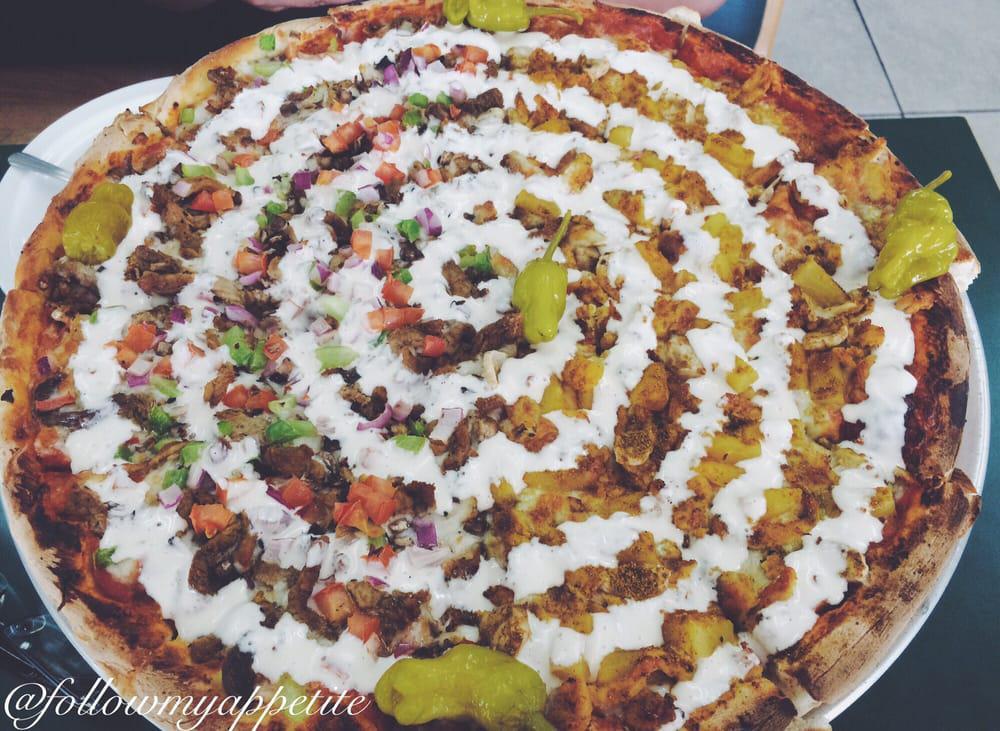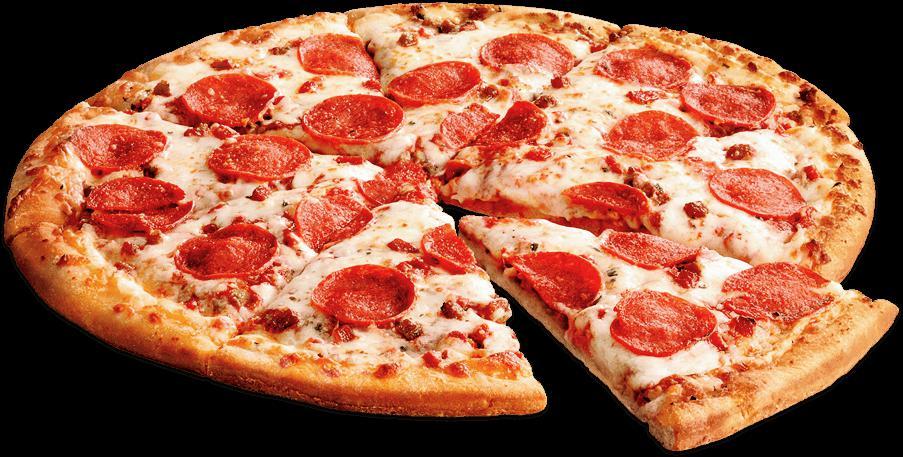The first image is the image on the left, the second image is the image on the right. For the images shown, is this caption "Both pizzas have a drizzle of white sauce on top." true? Answer yes or no. No. The first image is the image on the left, the second image is the image on the right. Analyze the images presented: Is the assertion "Each image shows a whole round pizza topped with a spiral of white cheese, and at least one pizza has a green chile pepper on top." valid? Answer yes or no. No. 